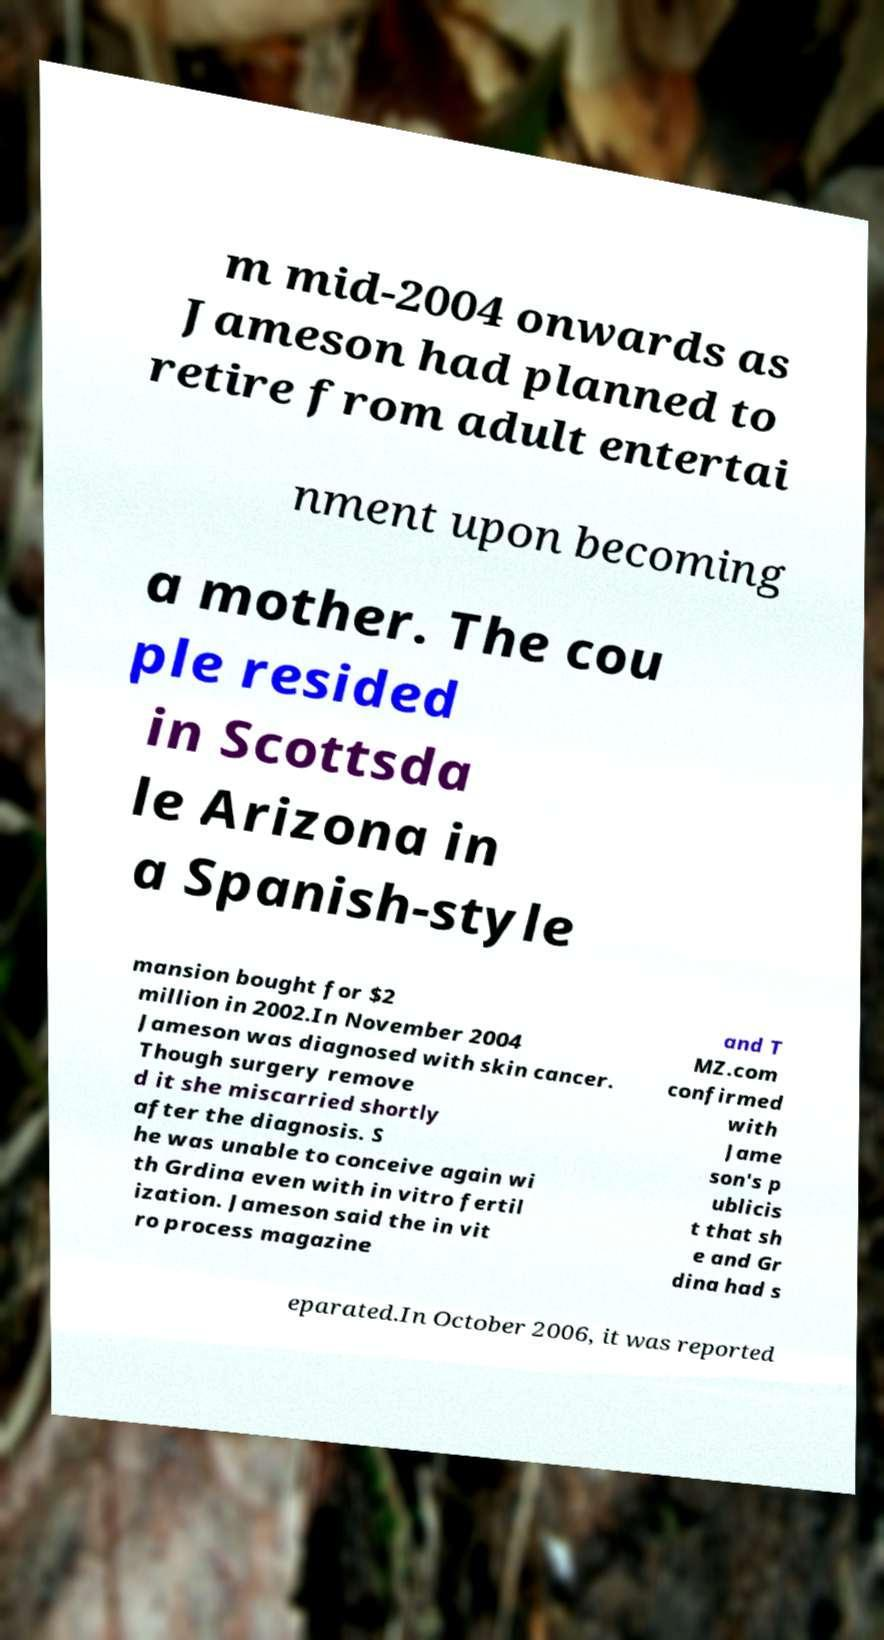There's text embedded in this image that I need extracted. Can you transcribe it verbatim? m mid-2004 onwards as Jameson had planned to retire from adult entertai nment upon becoming a mother. The cou ple resided in Scottsda le Arizona in a Spanish-style mansion bought for $2 million in 2002.In November 2004 Jameson was diagnosed with skin cancer. Though surgery remove d it she miscarried shortly after the diagnosis. S he was unable to conceive again wi th Grdina even with in vitro fertil ization. Jameson said the in vit ro process magazine and T MZ.com confirmed with Jame son's p ublicis t that sh e and Gr dina had s eparated.In October 2006, it was reported 